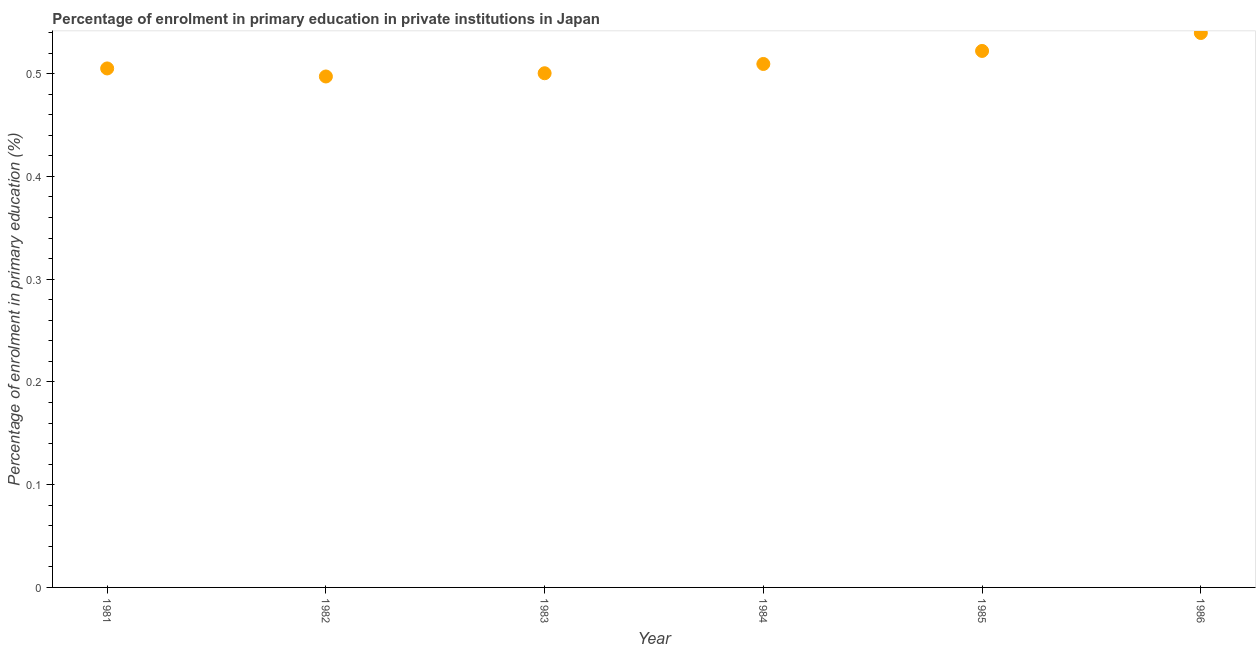What is the enrolment percentage in primary education in 1986?
Offer a terse response. 0.54. Across all years, what is the maximum enrolment percentage in primary education?
Offer a terse response. 0.54. Across all years, what is the minimum enrolment percentage in primary education?
Your answer should be very brief. 0.5. What is the sum of the enrolment percentage in primary education?
Ensure brevity in your answer.  3.07. What is the difference between the enrolment percentage in primary education in 1983 and 1984?
Offer a terse response. -0.01. What is the average enrolment percentage in primary education per year?
Make the answer very short. 0.51. What is the median enrolment percentage in primary education?
Provide a succinct answer. 0.51. In how many years, is the enrolment percentage in primary education greater than 0.06 %?
Your answer should be compact. 6. What is the ratio of the enrolment percentage in primary education in 1981 to that in 1984?
Ensure brevity in your answer.  0.99. Is the enrolment percentage in primary education in 1983 less than that in 1984?
Make the answer very short. Yes. Is the difference between the enrolment percentage in primary education in 1983 and 1986 greater than the difference between any two years?
Keep it short and to the point. No. What is the difference between the highest and the second highest enrolment percentage in primary education?
Make the answer very short. 0.02. What is the difference between the highest and the lowest enrolment percentage in primary education?
Give a very brief answer. 0.04. How many years are there in the graph?
Your answer should be very brief. 6. What is the difference between two consecutive major ticks on the Y-axis?
Provide a succinct answer. 0.1. Does the graph contain any zero values?
Provide a short and direct response. No. What is the title of the graph?
Your answer should be very brief. Percentage of enrolment in primary education in private institutions in Japan. What is the label or title of the X-axis?
Make the answer very short. Year. What is the label or title of the Y-axis?
Ensure brevity in your answer.  Percentage of enrolment in primary education (%). What is the Percentage of enrolment in primary education (%) in 1981?
Your answer should be very brief. 0.51. What is the Percentage of enrolment in primary education (%) in 1982?
Provide a short and direct response. 0.5. What is the Percentage of enrolment in primary education (%) in 1983?
Your answer should be compact. 0.5. What is the Percentage of enrolment in primary education (%) in 1984?
Your answer should be compact. 0.51. What is the Percentage of enrolment in primary education (%) in 1985?
Give a very brief answer. 0.52. What is the Percentage of enrolment in primary education (%) in 1986?
Ensure brevity in your answer.  0.54. What is the difference between the Percentage of enrolment in primary education (%) in 1981 and 1982?
Your response must be concise. 0.01. What is the difference between the Percentage of enrolment in primary education (%) in 1981 and 1983?
Provide a short and direct response. 0. What is the difference between the Percentage of enrolment in primary education (%) in 1981 and 1984?
Keep it short and to the point. -0. What is the difference between the Percentage of enrolment in primary education (%) in 1981 and 1985?
Give a very brief answer. -0.02. What is the difference between the Percentage of enrolment in primary education (%) in 1981 and 1986?
Provide a short and direct response. -0.03. What is the difference between the Percentage of enrolment in primary education (%) in 1982 and 1983?
Your response must be concise. -0. What is the difference between the Percentage of enrolment in primary education (%) in 1982 and 1984?
Your response must be concise. -0.01. What is the difference between the Percentage of enrolment in primary education (%) in 1982 and 1985?
Ensure brevity in your answer.  -0.02. What is the difference between the Percentage of enrolment in primary education (%) in 1982 and 1986?
Your answer should be very brief. -0.04. What is the difference between the Percentage of enrolment in primary education (%) in 1983 and 1984?
Give a very brief answer. -0.01. What is the difference between the Percentage of enrolment in primary education (%) in 1983 and 1985?
Your answer should be very brief. -0.02. What is the difference between the Percentage of enrolment in primary education (%) in 1983 and 1986?
Make the answer very short. -0.04. What is the difference between the Percentage of enrolment in primary education (%) in 1984 and 1985?
Your response must be concise. -0.01. What is the difference between the Percentage of enrolment in primary education (%) in 1984 and 1986?
Your answer should be compact. -0.03. What is the difference between the Percentage of enrolment in primary education (%) in 1985 and 1986?
Make the answer very short. -0.02. What is the ratio of the Percentage of enrolment in primary education (%) in 1981 to that in 1982?
Your answer should be very brief. 1.02. What is the ratio of the Percentage of enrolment in primary education (%) in 1981 to that in 1983?
Keep it short and to the point. 1.01. What is the ratio of the Percentage of enrolment in primary education (%) in 1981 to that in 1984?
Keep it short and to the point. 0.99. What is the ratio of the Percentage of enrolment in primary education (%) in 1981 to that in 1985?
Offer a very short reply. 0.97. What is the ratio of the Percentage of enrolment in primary education (%) in 1981 to that in 1986?
Offer a very short reply. 0.94. What is the ratio of the Percentage of enrolment in primary education (%) in 1982 to that in 1984?
Ensure brevity in your answer.  0.98. What is the ratio of the Percentage of enrolment in primary education (%) in 1982 to that in 1985?
Provide a succinct answer. 0.95. What is the ratio of the Percentage of enrolment in primary education (%) in 1982 to that in 1986?
Give a very brief answer. 0.92. What is the ratio of the Percentage of enrolment in primary education (%) in 1983 to that in 1985?
Offer a terse response. 0.96. What is the ratio of the Percentage of enrolment in primary education (%) in 1983 to that in 1986?
Your response must be concise. 0.93. What is the ratio of the Percentage of enrolment in primary education (%) in 1984 to that in 1986?
Keep it short and to the point. 0.94. 